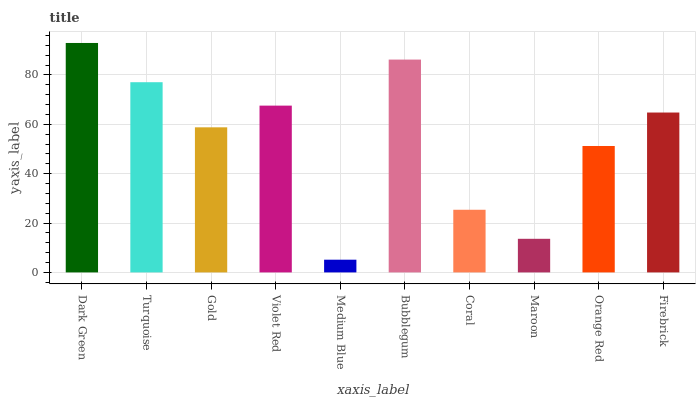Is Medium Blue the minimum?
Answer yes or no. Yes. Is Dark Green the maximum?
Answer yes or no. Yes. Is Turquoise the minimum?
Answer yes or no. No. Is Turquoise the maximum?
Answer yes or no. No. Is Dark Green greater than Turquoise?
Answer yes or no. Yes. Is Turquoise less than Dark Green?
Answer yes or no. Yes. Is Turquoise greater than Dark Green?
Answer yes or no. No. Is Dark Green less than Turquoise?
Answer yes or no. No. Is Firebrick the high median?
Answer yes or no. Yes. Is Gold the low median?
Answer yes or no. Yes. Is Medium Blue the high median?
Answer yes or no. No. Is Coral the low median?
Answer yes or no. No. 